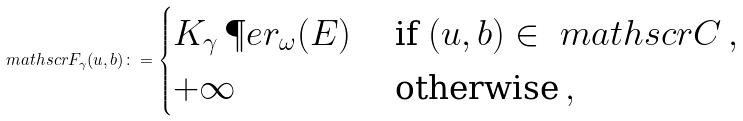Convert formula to latex. <formula><loc_0><loc_0><loc_500><loc_500>\ m a t h s c r { F } _ { \gamma } ( u , b ) \colon = \begin{cases} K _ { \gamma } \, \P e r _ { \omega } ( E ) & \text { if } ( u , b ) \in \ m a t h s c r { C } \, , \\ + \infty & \text { otherwise} \, , \end{cases}</formula> 